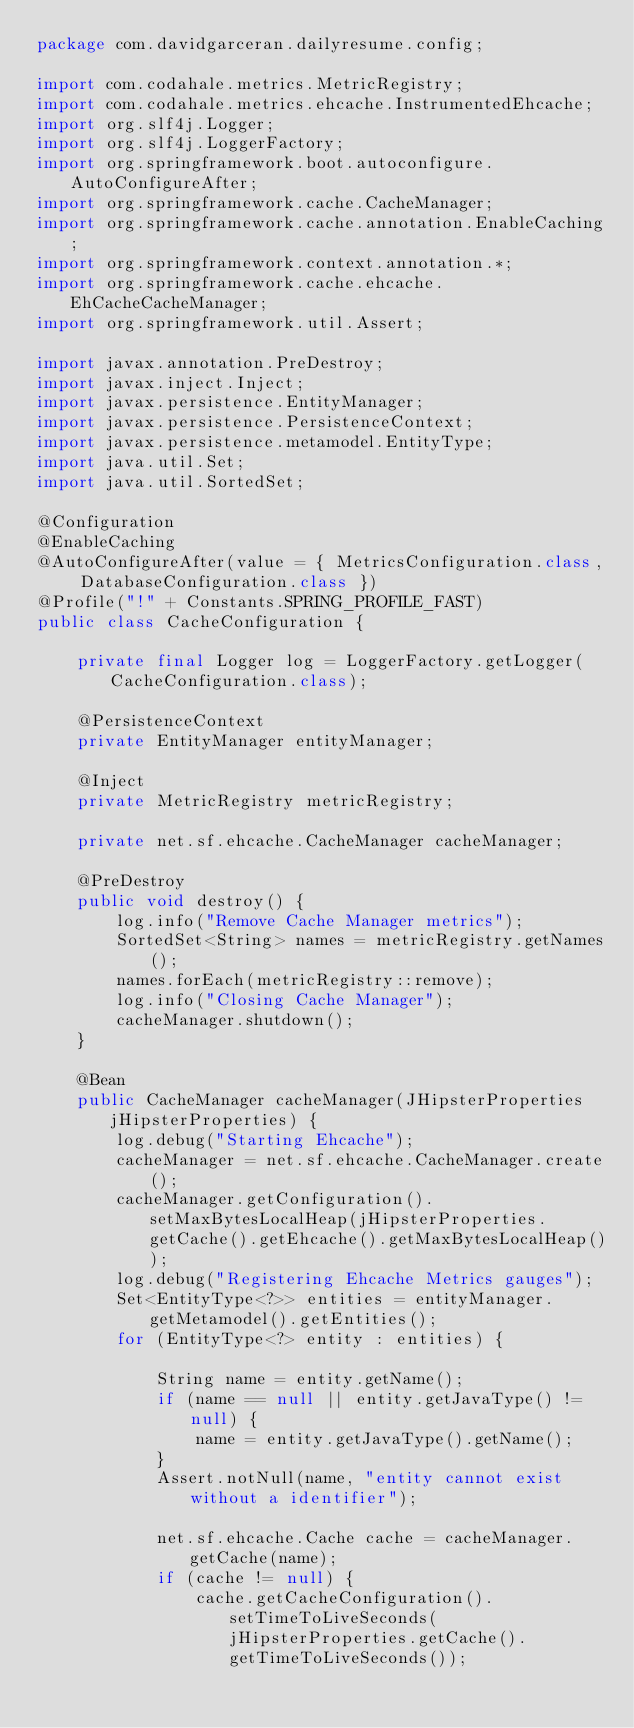<code> <loc_0><loc_0><loc_500><loc_500><_Java_>package com.davidgarceran.dailyresume.config;

import com.codahale.metrics.MetricRegistry;
import com.codahale.metrics.ehcache.InstrumentedEhcache;
import org.slf4j.Logger;
import org.slf4j.LoggerFactory;
import org.springframework.boot.autoconfigure.AutoConfigureAfter;
import org.springframework.cache.CacheManager;
import org.springframework.cache.annotation.EnableCaching;
import org.springframework.context.annotation.*;
import org.springframework.cache.ehcache.EhCacheCacheManager;
import org.springframework.util.Assert;

import javax.annotation.PreDestroy;
import javax.inject.Inject;
import javax.persistence.EntityManager;
import javax.persistence.PersistenceContext;
import javax.persistence.metamodel.EntityType;
import java.util.Set;
import java.util.SortedSet;

@Configuration
@EnableCaching
@AutoConfigureAfter(value = { MetricsConfiguration.class, DatabaseConfiguration.class })
@Profile("!" + Constants.SPRING_PROFILE_FAST)
public class CacheConfiguration {

    private final Logger log = LoggerFactory.getLogger(CacheConfiguration.class);

    @PersistenceContext
    private EntityManager entityManager;

    @Inject
    private MetricRegistry metricRegistry;

    private net.sf.ehcache.CacheManager cacheManager;

    @PreDestroy
    public void destroy() {
        log.info("Remove Cache Manager metrics");
        SortedSet<String> names = metricRegistry.getNames();
        names.forEach(metricRegistry::remove);
        log.info("Closing Cache Manager");
        cacheManager.shutdown();
    }

    @Bean
    public CacheManager cacheManager(JHipsterProperties jHipsterProperties) {
        log.debug("Starting Ehcache");
        cacheManager = net.sf.ehcache.CacheManager.create();
        cacheManager.getConfiguration().setMaxBytesLocalHeap(jHipsterProperties.getCache().getEhcache().getMaxBytesLocalHeap());
        log.debug("Registering Ehcache Metrics gauges");
        Set<EntityType<?>> entities = entityManager.getMetamodel().getEntities();
        for (EntityType<?> entity : entities) {

            String name = entity.getName();
            if (name == null || entity.getJavaType() != null) {
                name = entity.getJavaType().getName();
            }
            Assert.notNull(name, "entity cannot exist without a identifier");

            net.sf.ehcache.Cache cache = cacheManager.getCache(name);
            if (cache != null) {
                cache.getCacheConfiguration().setTimeToLiveSeconds(jHipsterProperties.getCache().getTimeToLiveSeconds());</code> 